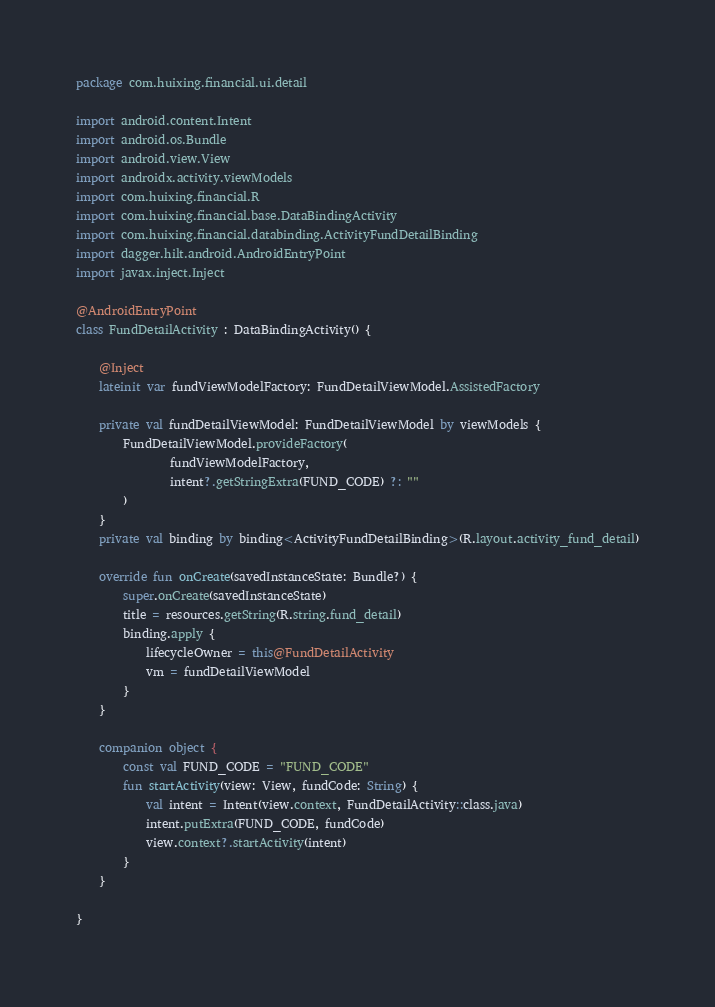Convert code to text. <code><loc_0><loc_0><loc_500><loc_500><_Kotlin_>package com.huixing.financial.ui.detail

import android.content.Intent
import android.os.Bundle
import android.view.View
import androidx.activity.viewModels
import com.huixing.financial.R
import com.huixing.financial.base.DataBindingActivity
import com.huixing.financial.databinding.ActivityFundDetailBinding
import dagger.hilt.android.AndroidEntryPoint
import javax.inject.Inject

@AndroidEntryPoint
class FundDetailActivity : DataBindingActivity() {

    @Inject
    lateinit var fundViewModelFactory: FundDetailViewModel.AssistedFactory

    private val fundDetailViewModel: FundDetailViewModel by viewModels {
        FundDetailViewModel.provideFactory(
                fundViewModelFactory,
                intent?.getStringExtra(FUND_CODE) ?: ""
        )
    }
    private val binding by binding<ActivityFundDetailBinding>(R.layout.activity_fund_detail)

    override fun onCreate(savedInstanceState: Bundle?) {
        super.onCreate(savedInstanceState)
        title = resources.getString(R.string.fund_detail)
        binding.apply {
            lifecycleOwner = this@FundDetailActivity
            vm = fundDetailViewModel
        }
    }

    companion object {
        const val FUND_CODE = "FUND_CODE"
        fun startActivity(view: View, fundCode: String) {
            val intent = Intent(view.context, FundDetailActivity::class.java)
            intent.putExtra(FUND_CODE, fundCode)
            view.context?.startActivity(intent)
        }
    }

}</code> 